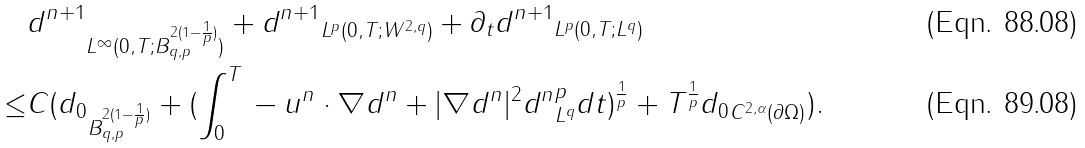Convert formula to latex. <formula><loc_0><loc_0><loc_500><loc_500>& \| d ^ { n + 1 } \| _ { L ^ { \infty } ( 0 , T ; B _ { q , p } ^ { 2 ( 1 - \frac { 1 } { p } ) } ) } + \| d ^ { n + 1 } \| _ { L ^ { p } ( 0 , T ; W ^ { 2 , q } ) } + \| \partial _ { t } d ^ { n + 1 } \| _ { L ^ { p } ( 0 , T ; L ^ { q } ) } \\ \leq & C ( \| d _ { 0 } \| _ { B _ { q , p } ^ { 2 ( 1 - \frac { 1 } { p } ) } } + ( \int _ { 0 } ^ { T } \| - u ^ { n } \cdot \nabla d ^ { n } + | \nabla d ^ { n } | ^ { 2 } d ^ { n } \| ^ { p } _ { L ^ { q } } d t ) ^ { \frac { 1 } { p } } + T ^ { \frac { 1 } { p } } \| d _ { 0 } \| _ { C ^ { 2 , \alpha } ( \partial \Omega ) } ) .</formula> 